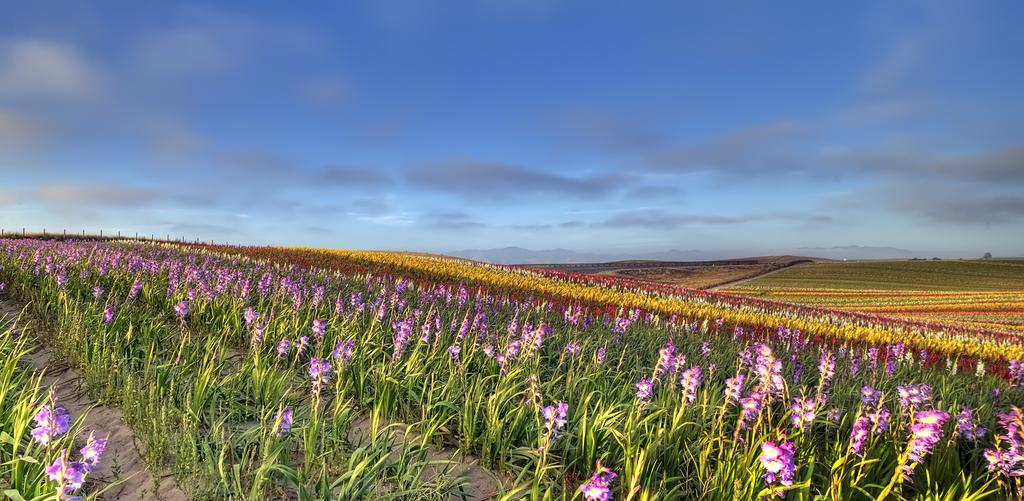What types of flowers can be seen in the image? There are flowers of different colors in the image. Where are the flowers located? The flowers are on plants. What can be seen in the sky at the top of the image? There are clouds visible in the sky. What type of pet can be seen playing with the zephyr in the image? There is no pet or zephyr present in the image; it features flowers on plants and clouds in the sky. 